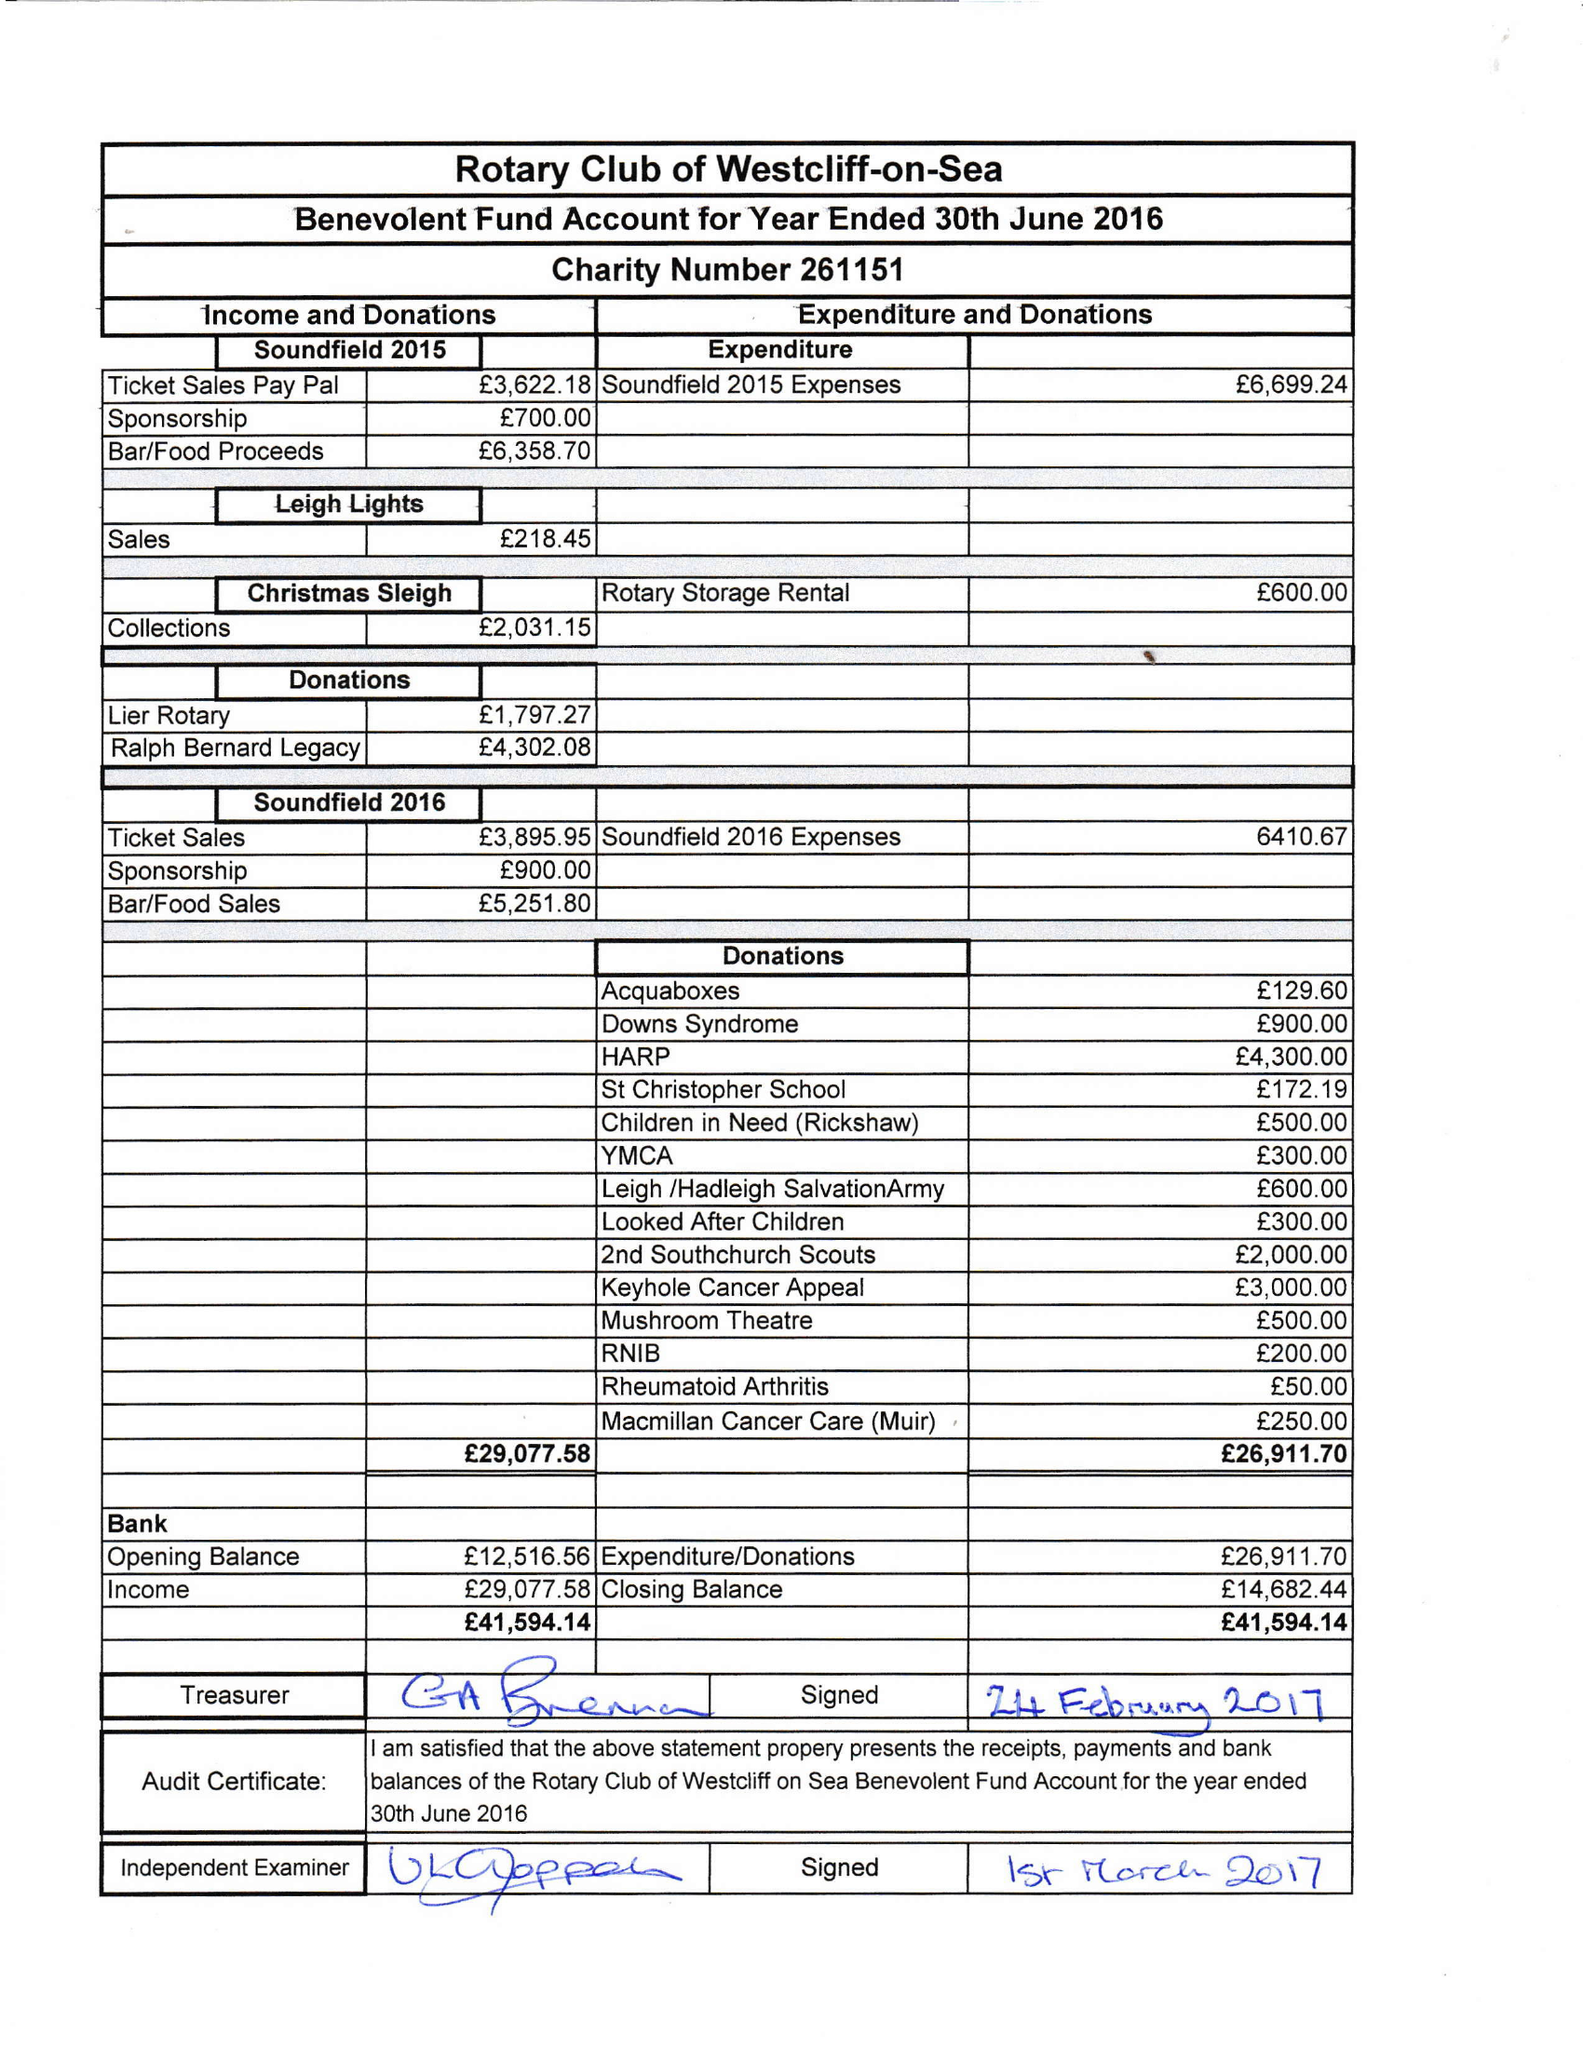What is the value for the report_date?
Answer the question using a single word or phrase. 2016-06-30 